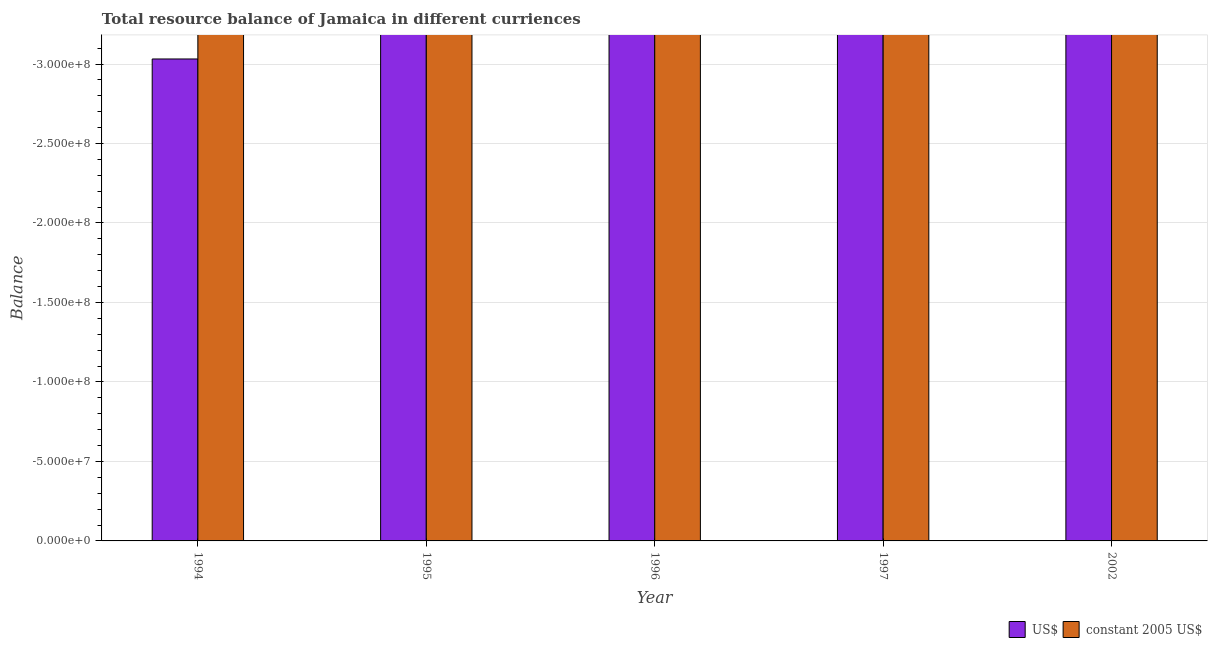How many different coloured bars are there?
Your response must be concise. 0. Are the number of bars on each tick of the X-axis equal?
Provide a succinct answer. Yes. How many bars are there on the 5th tick from the left?
Offer a terse response. 0. What is the label of the 1st group of bars from the left?
Make the answer very short. 1994. What is the total resource balance in us$ in the graph?
Make the answer very short. 0. What is the difference between the resource balance in us$ in 1996 and the resource balance in constant us$ in 2002?
Offer a very short reply. 0. What is the average resource balance in us$ per year?
Offer a very short reply. 0. How many bars are there?
Your answer should be compact. 0. Are all the bars in the graph horizontal?
Ensure brevity in your answer.  No. Does the graph contain grids?
Your answer should be compact. Yes. What is the title of the graph?
Your response must be concise. Total resource balance of Jamaica in different curriences. Does "State government" appear as one of the legend labels in the graph?
Ensure brevity in your answer.  No. What is the label or title of the X-axis?
Your response must be concise. Year. What is the label or title of the Y-axis?
Keep it short and to the point. Balance. What is the Balance in US$ in 1994?
Your response must be concise. 0. What is the Balance in US$ in 1996?
Keep it short and to the point. 0. What is the Balance in constant 2005 US$ in 1996?
Your answer should be very brief. 0. What is the Balance in US$ in 1997?
Your answer should be very brief. 0. What is the total Balance of US$ in the graph?
Make the answer very short. 0. What is the total Balance of constant 2005 US$ in the graph?
Keep it short and to the point. 0. What is the average Balance of constant 2005 US$ per year?
Your answer should be very brief. 0. 